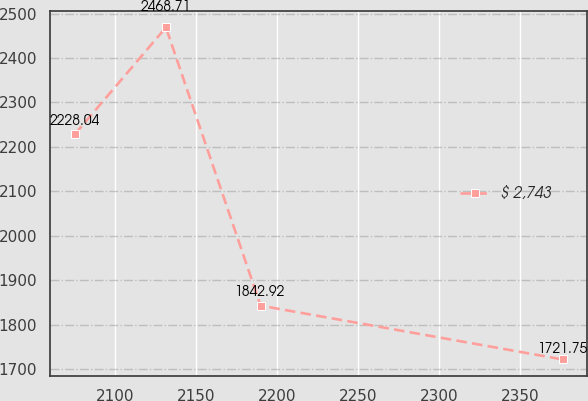Convert chart. <chart><loc_0><loc_0><loc_500><loc_500><line_chart><ecel><fcel>$ 2,743<nl><fcel>2075.37<fcel>2228.04<nl><fcel>2131.62<fcel>2468.71<nl><fcel>2189.98<fcel>1842.92<nl><fcel>2376.36<fcel>1721.75<nl></chart> 